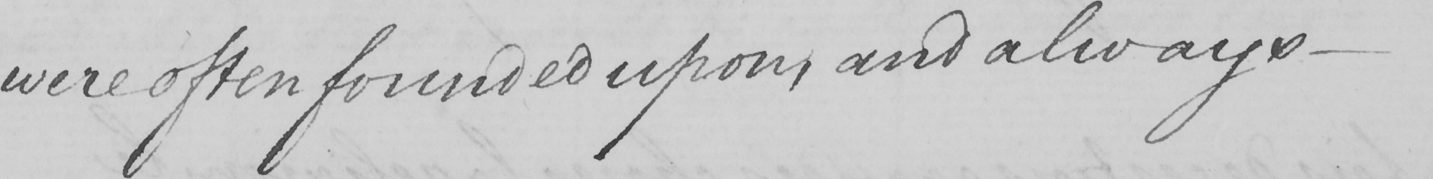Please transcribe the handwritten text in this image. were often founded upon , and always  _ 